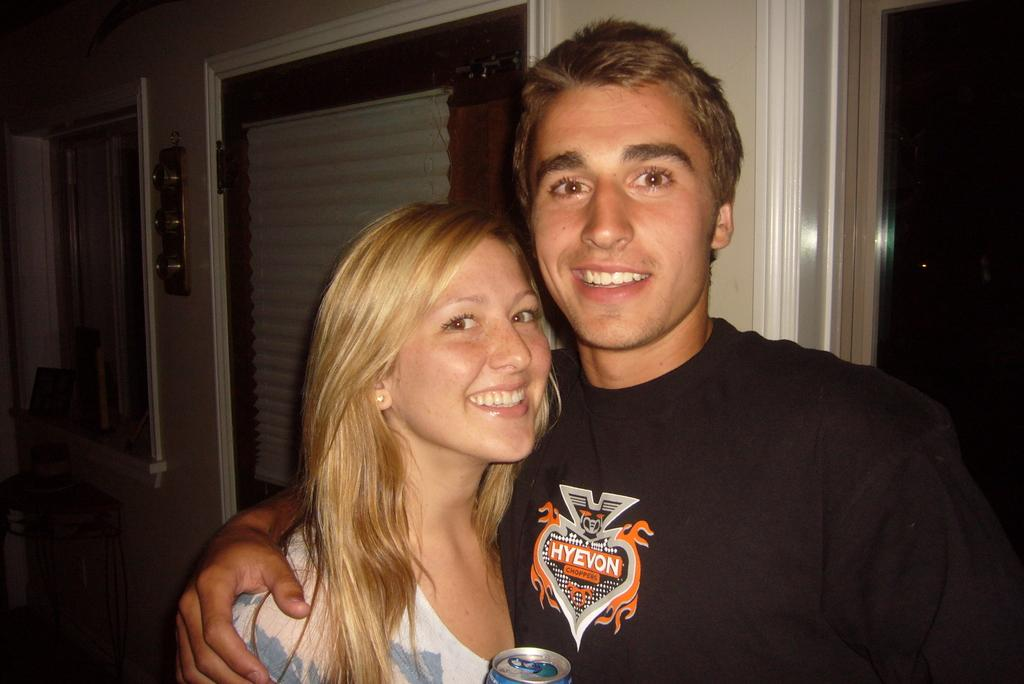How many people are present in the image? There is a man and a woman in the image. What can be seen in the background of the image? There is a wall in the background of the image. What architectural features are present in the wall? There is a door and a window in the wall. What type of apple can be seen on the ground in the image? There is no apple present in the image; it only features a man, a woman, a wall, a door, and a window. 